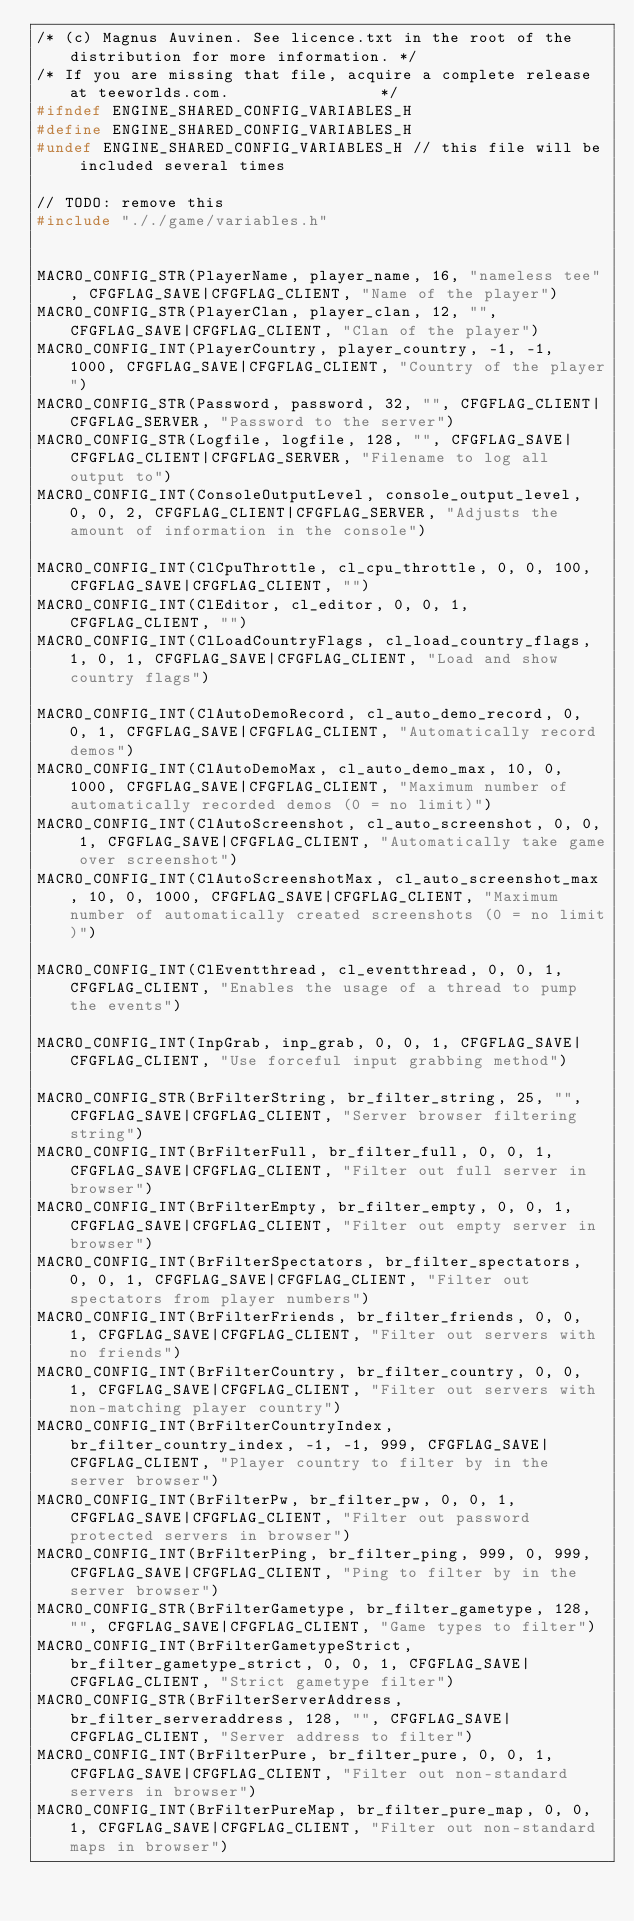<code> <loc_0><loc_0><loc_500><loc_500><_C_>/* (c) Magnus Auvinen. See licence.txt in the root of the distribution for more information. */
/* If you are missing that file, acquire a complete release at teeworlds.com.                */
#ifndef ENGINE_SHARED_CONFIG_VARIABLES_H
#define ENGINE_SHARED_CONFIG_VARIABLES_H
#undef ENGINE_SHARED_CONFIG_VARIABLES_H // this file will be included several times

// TODO: remove this
#include "././game/variables.h"


MACRO_CONFIG_STR(PlayerName, player_name, 16, "nameless tee", CFGFLAG_SAVE|CFGFLAG_CLIENT, "Name of the player")
MACRO_CONFIG_STR(PlayerClan, player_clan, 12, "", CFGFLAG_SAVE|CFGFLAG_CLIENT, "Clan of the player")
MACRO_CONFIG_INT(PlayerCountry, player_country, -1, -1, 1000, CFGFLAG_SAVE|CFGFLAG_CLIENT, "Country of the player")
MACRO_CONFIG_STR(Password, password, 32, "", CFGFLAG_CLIENT|CFGFLAG_SERVER, "Password to the server")
MACRO_CONFIG_STR(Logfile, logfile, 128, "", CFGFLAG_SAVE|CFGFLAG_CLIENT|CFGFLAG_SERVER, "Filename to log all output to")
MACRO_CONFIG_INT(ConsoleOutputLevel, console_output_level, 0, 0, 2, CFGFLAG_CLIENT|CFGFLAG_SERVER, "Adjusts the amount of information in the console")

MACRO_CONFIG_INT(ClCpuThrottle, cl_cpu_throttle, 0, 0, 100, CFGFLAG_SAVE|CFGFLAG_CLIENT, "")
MACRO_CONFIG_INT(ClEditor, cl_editor, 0, 0, 1, CFGFLAG_CLIENT, "")
MACRO_CONFIG_INT(ClLoadCountryFlags, cl_load_country_flags, 1, 0, 1, CFGFLAG_SAVE|CFGFLAG_CLIENT, "Load and show country flags")

MACRO_CONFIG_INT(ClAutoDemoRecord, cl_auto_demo_record, 0, 0, 1, CFGFLAG_SAVE|CFGFLAG_CLIENT, "Automatically record demos")
MACRO_CONFIG_INT(ClAutoDemoMax, cl_auto_demo_max, 10, 0, 1000, CFGFLAG_SAVE|CFGFLAG_CLIENT, "Maximum number of automatically recorded demos (0 = no limit)")
MACRO_CONFIG_INT(ClAutoScreenshot, cl_auto_screenshot, 0, 0, 1, CFGFLAG_SAVE|CFGFLAG_CLIENT, "Automatically take game over screenshot")
MACRO_CONFIG_INT(ClAutoScreenshotMax, cl_auto_screenshot_max, 10, 0, 1000, CFGFLAG_SAVE|CFGFLAG_CLIENT, "Maximum number of automatically created screenshots (0 = no limit)")

MACRO_CONFIG_INT(ClEventthread, cl_eventthread, 0, 0, 1, CFGFLAG_CLIENT, "Enables the usage of a thread to pump the events")

MACRO_CONFIG_INT(InpGrab, inp_grab, 0, 0, 1, CFGFLAG_SAVE|CFGFLAG_CLIENT, "Use forceful input grabbing method")

MACRO_CONFIG_STR(BrFilterString, br_filter_string, 25, "", CFGFLAG_SAVE|CFGFLAG_CLIENT, "Server browser filtering string")
MACRO_CONFIG_INT(BrFilterFull, br_filter_full, 0, 0, 1, CFGFLAG_SAVE|CFGFLAG_CLIENT, "Filter out full server in browser")
MACRO_CONFIG_INT(BrFilterEmpty, br_filter_empty, 0, 0, 1, CFGFLAG_SAVE|CFGFLAG_CLIENT, "Filter out empty server in browser")
MACRO_CONFIG_INT(BrFilterSpectators, br_filter_spectators, 0, 0, 1, CFGFLAG_SAVE|CFGFLAG_CLIENT, "Filter out spectators from player numbers")
MACRO_CONFIG_INT(BrFilterFriends, br_filter_friends, 0, 0, 1, CFGFLAG_SAVE|CFGFLAG_CLIENT, "Filter out servers with no friends")
MACRO_CONFIG_INT(BrFilterCountry, br_filter_country, 0, 0, 1, CFGFLAG_SAVE|CFGFLAG_CLIENT, "Filter out servers with non-matching player country")
MACRO_CONFIG_INT(BrFilterCountryIndex, br_filter_country_index, -1, -1, 999, CFGFLAG_SAVE|CFGFLAG_CLIENT, "Player country to filter by in the server browser")
MACRO_CONFIG_INT(BrFilterPw, br_filter_pw, 0, 0, 1, CFGFLAG_SAVE|CFGFLAG_CLIENT, "Filter out password protected servers in browser")
MACRO_CONFIG_INT(BrFilterPing, br_filter_ping, 999, 0, 999, CFGFLAG_SAVE|CFGFLAG_CLIENT, "Ping to filter by in the server browser")
MACRO_CONFIG_STR(BrFilterGametype, br_filter_gametype, 128, "", CFGFLAG_SAVE|CFGFLAG_CLIENT, "Game types to filter")
MACRO_CONFIG_INT(BrFilterGametypeStrict, br_filter_gametype_strict, 0, 0, 1, CFGFLAG_SAVE|CFGFLAG_CLIENT, "Strict gametype filter")
MACRO_CONFIG_STR(BrFilterServerAddress, br_filter_serveraddress, 128, "", CFGFLAG_SAVE|CFGFLAG_CLIENT, "Server address to filter")
MACRO_CONFIG_INT(BrFilterPure, br_filter_pure, 0, 0, 1, CFGFLAG_SAVE|CFGFLAG_CLIENT, "Filter out non-standard servers in browser")
MACRO_CONFIG_INT(BrFilterPureMap, br_filter_pure_map, 0, 0, 1, CFGFLAG_SAVE|CFGFLAG_CLIENT, "Filter out non-standard maps in browser")</code> 